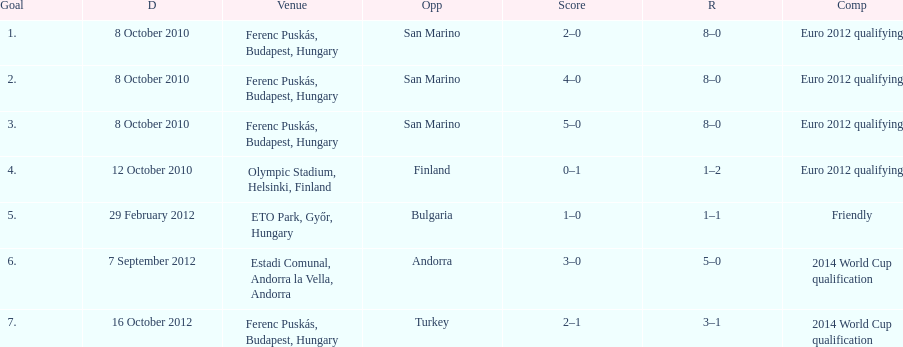When did ádám szalai achieve his first international goal? 8 October 2010. 